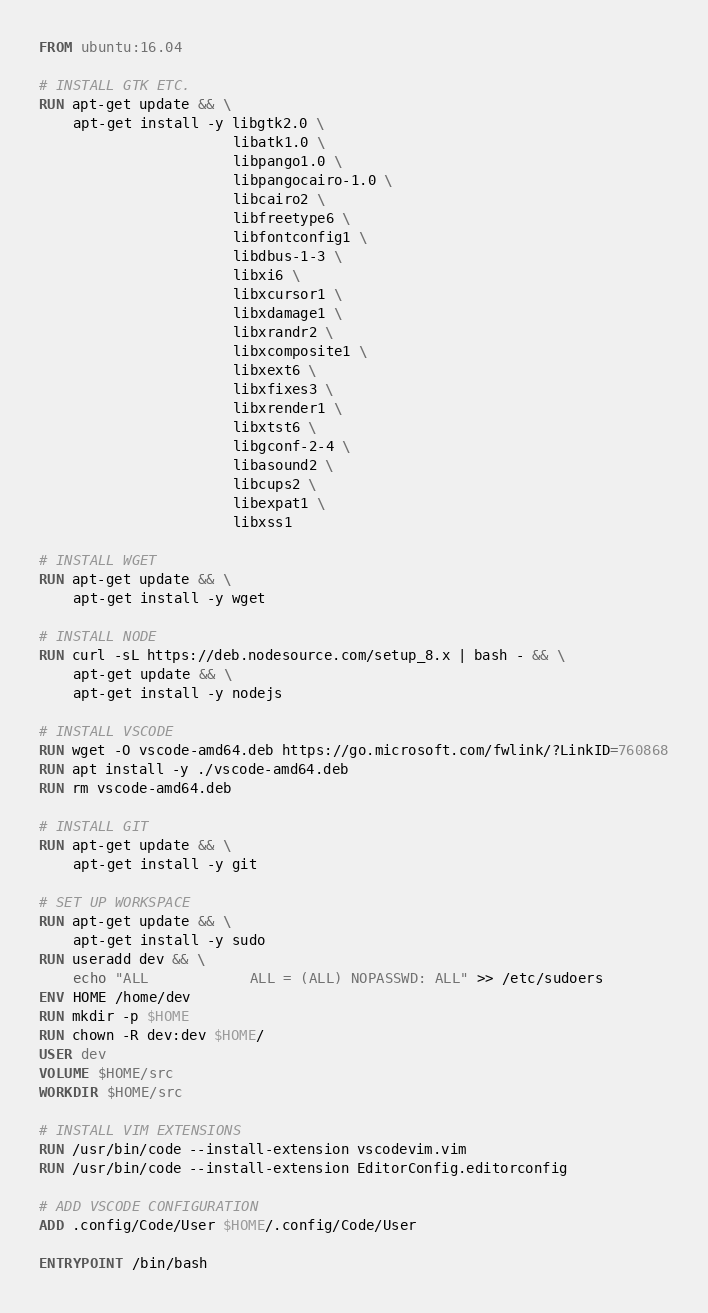Convert code to text. <code><loc_0><loc_0><loc_500><loc_500><_Dockerfile_>FROM ubuntu:16.04

# INSTALL GTK ETC.
RUN apt-get update && \
    apt-get install -y libgtk2.0 \
                       libatk1.0 \
                       libpango1.0 \
                       libpangocairo-1.0 \
                       libcairo2 \
                       libfreetype6 \
                       libfontconfig1 \
                       libdbus-1-3 \
                       libxi6 \
                       libxcursor1 \
                       libxdamage1 \
                       libxrandr2 \
                       libxcomposite1 \
                       libxext6 \
                       libxfixes3 \
                       libxrender1 \
                       libxtst6 \
                       libgconf-2-4 \
                       libasound2 \
                       libcups2 \
                       libexpat1 \
                       libxss1

# INSTALL WGET
RUN apt-get update && \
    apt-get install -y wget

# INSTALL NODE
RUN curl -sL https://deb.nodesource.com/setup_8.x | bash - && \
    apt-get update && \
    apt-get install -y nodejs

# INSTALL VSCODE
RUN wget -O vscode-amd64.deb https://go.microsoft.com/fwlink/?LinkID=760868
RUN apt install -y ./vscode-amd64.deb
RUN rm vscode-amd64.deb

# INSTALL GIT
RUN apt-get update && \
    apt-get install -y git

# SET UP WORKSPACE
RUN apt-get update && \
    apt-get install -y sudo
RUN useradd dev && \
    echo "ALL            ALL = (ALL) NOPASSWD: ALL" >> /etc/sudoers
ENV HOME /home/dev
RUN mkdir -p $HOME
RUN chown -R dev:dev $HOME/
USER dev
VOLUME $HOME/src
WORKDIR $HOME/src

# INSTALL VIM EXTENSIONS
RUN /usr/bin/code --install-extension vscodevim.vim
RUN /usr/bin/code --install-extension EditorConfig.editorconfig

# ADD VSCODE CONFIGURATION
ADD .config/Code/User $HOME/.config/Code/User

ENTRYPOINT /bin/bash
</code> 